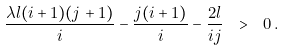<formula> <loc_0><loc_0><loc_500><loc_500>\frac { \lambda l ( i + 1 ) ( j + 1 ) } { i } - \frac { j ( i + 1 ) } { i } - \frac { 2 l } { i j } \ > \ 0 \, .</formula> 